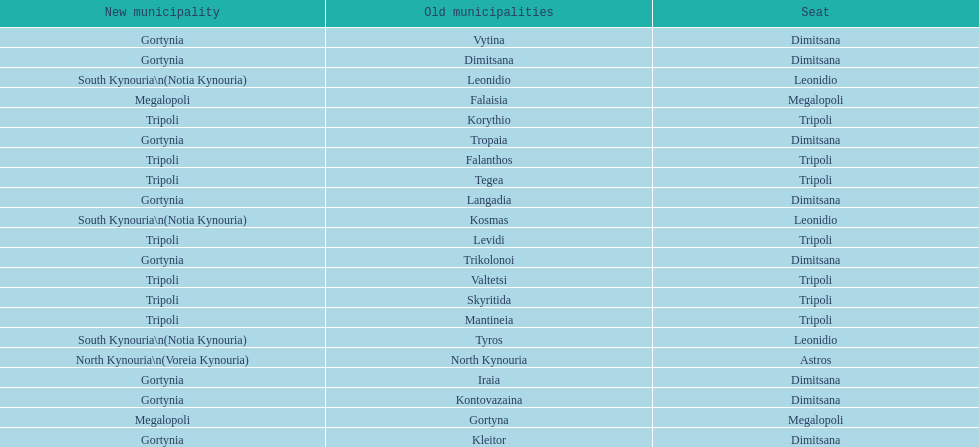What is the new municipality of tyros? South Kynouria. 